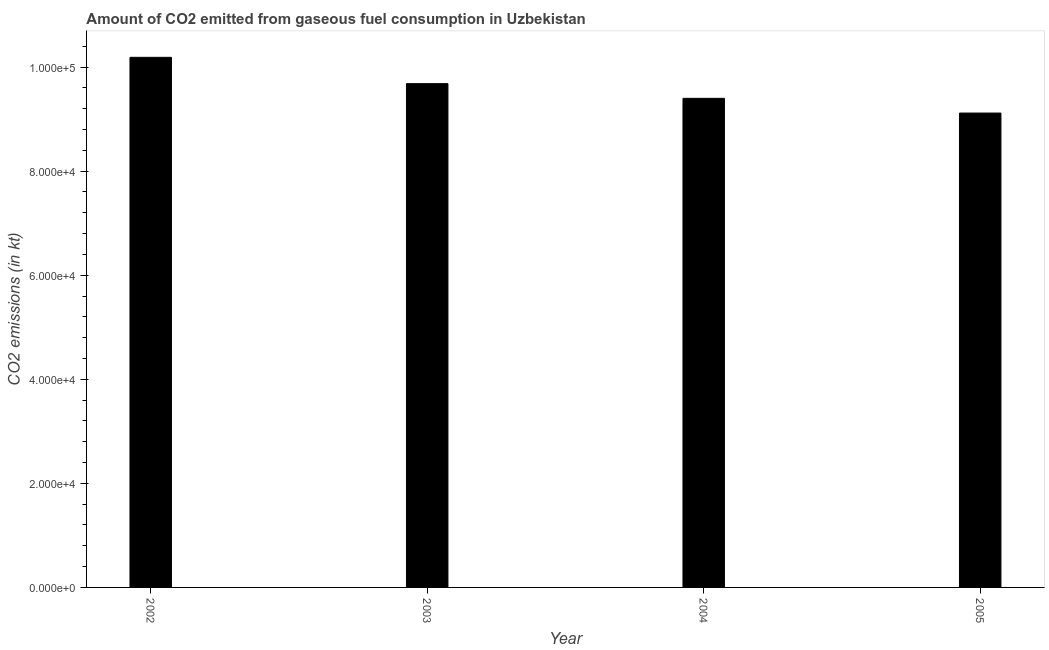Does the graph contain any zero values?
Your answer should be compact. No. What is the title of the graph?
Provide a succinct answer. Amount of CO2 emitted from gaseous fuel consumption in Uzbekistan. What is the label or title of the X-axis?
Make the answer very short. Year. What is the label or title of the Y-axis?
Provide a short and direct response. CO2 emissions (in kt). What is the co2 emissions from gaseous fuel consumption in 2004?
Your answer should be compact. 9.40e+04. Across all years, what is the maximum co2 emissions from gaseous fuel consumption?
Give a very brief answer. 1.02e+05. Across all years, what is the minimum co2 emissions from gaseous fuel consumption?
Provide a short and direct response. 9.12e+04. What is the sum of the co2 emissions from gaseous fuel consumption?
Your answer should be very brief. 3.84e+05. What is the difference between the co2 emissions from gaseous fuel consumption in 2004 and 2005?
Your response must be concise. 2827.26. What is the average co2 emissions from gaseous fuel consumption per year?
Offer a very short reply. 9.60e+04. What is the median co2 emissions from gaseous fuel consumption?
Provide a succinct answer. 9.54e+04. What is the ratio of the co2 emissions from gaseous fuel consumption in 2003 to that in 2005?
Your response must be concise. 1.06. What is the difference between the highest and the second highest co2 emissions from gaseous fuel consumption?
Give a very brief answer. 5056.79. What is the difference between the highest and the lowest co2 emissions from gaseous fuel consumption?
Your answer should be very brief. 1.07e+04. In how many years, is the co2 emissions from gaseous fuel consumption greater than the average co2 emissions from gaseous fuel consumption taken over all years?
Ensure brevity in your answer.  2. What is the difference between two consecutive major ticks on the Y-axis?
Keep it short and to the point. 2.00e+04. Are the values on the major ticks of Y-axis written in scientific E-notation?
Offer a terse response. Yes. What is the CO2 emissions (in kt) of 2002?
Ensure brevity in your answer.  1.02e+05. What is the CO2 emissions (in kt) in 2003?
Offer a terse response. 9.68e+04. What is the CO2 emissions (in kt) in 2004?
Your answer should be very brief. 9.40e+04. What is the CO2 emissions (in kt) in 2005?
Your answer should be compact. 9.12e+04. What is the difference between the CO2 emissions (in kt) in 2002 and 2003?
Ensure brevity in your answer.  5056.79. What is the difference between the CO2 emissions (in kt) in 2002 and 2004?
Keep it short and to the point. 7880.38. What is the difference between the CO2 emissions (in kt) in 2002 and 2005?
Your answer should be compact. 1.07e+04. What is the difference between the CO2 emissions (in kt) in 2003 and 2004?
Give a very brief answer. 2823.59. What is the difference between the CO2 emissions (in kt) in 2003 and 2005?
Make the answer very short. 5650.85. What is the difference between the CO2 emissions (in kt) in 2004 and 2005?
Provide a succinct answer. 2827.26. What is the ratio of the CO2 emissions (in kt) in 2002 to that in 2003?
Keep it short and to the point. 1.05. What is the ratio of the CO2 emissions (in kt) in 2002 to that in 2004?
Your answer should be compact. 1.08. What is the ratio of the CO2 emissions (in kt) in 2002 to that in 2005?
Keep it short and to the point. 1.12. What is the ratio of the CO2 emissions (in kt) in 2003 to that in 2004?
Ensure brevity in your answer.  1.03. What is the ratio of the CO2 emissions (in kt) in 2003 to that in 2005?
Offer a terse response. 1.06. What is the ratio of the CO2 emissions (in kt) in 2004 to that in 2005?
Give a very brief answer. 1.03. 